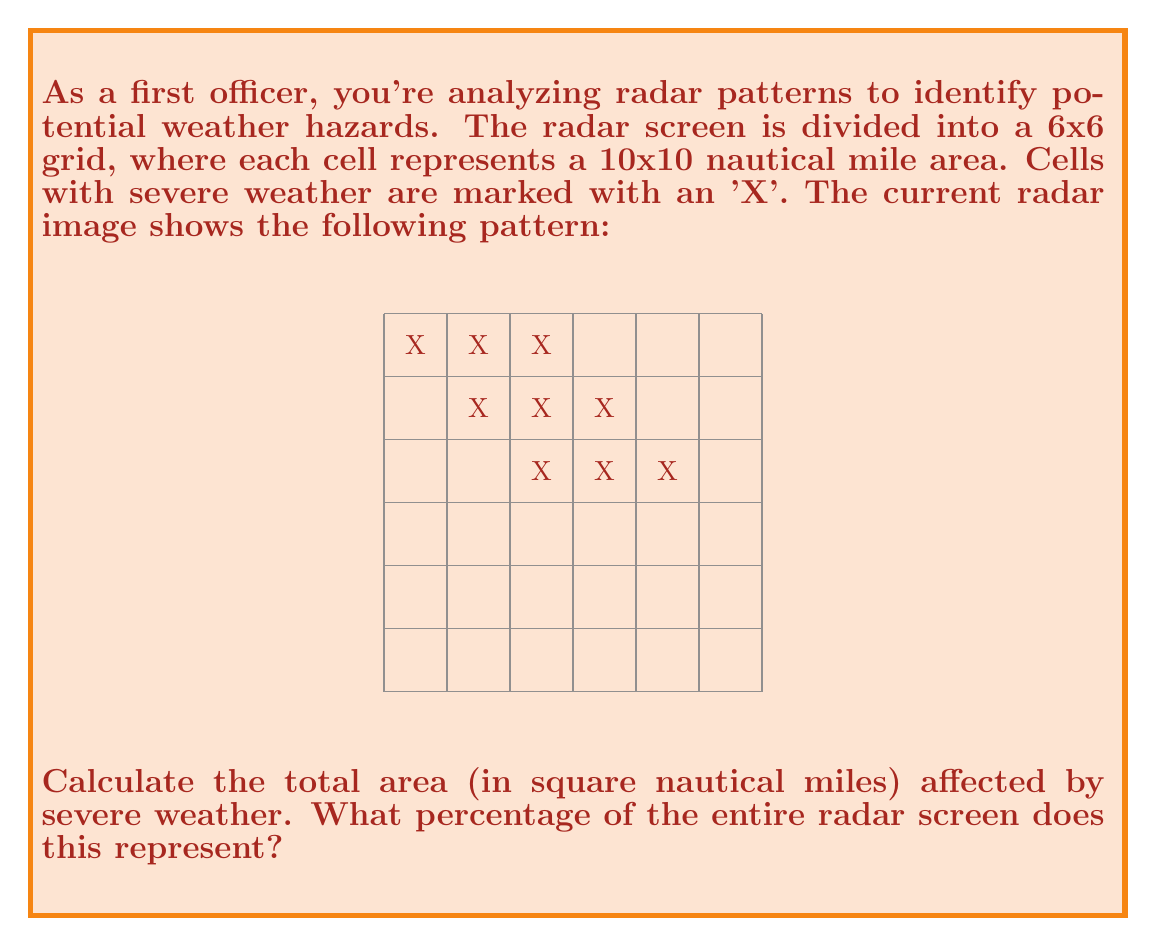Can you solve this math problem? Let's approach this step-by-step:

1. Count the number of cells marked with 'X':
   There are 9 cells marked with 'X'.

2. Calculate the area of each cell:
   Each cell represents a 10x10 nautical mile area.
   Area per cell = $10 \times 10 = 100$ square nautical miles

3. Calculate the total area affected by severe weather:
   Total affected area = Number of marked cells × Area per cell
   $$ \text{Total affected area} = 9 \times 100 = 900 \text{ square nautical miles} $$

4. Calculate the total area of the radar screen:
   The screen is a 6x6 grid, so it's 60x60 nautical miles.
   $$ \text{Total screen area} = 60 \times 60 = 3600 \text{ square nautical miles} $$

5. Calculate the percentage of the screen affected:
   $$ \text{Percentage} = \frac{\text{Affected area}}{\text{Total area}} \times 100\% $$
   $$ = \frac{900}{3600} \times 100\% = 0.25 \times 100\% = 25\% $$

Therefore, 900 square nautical miles are affected by severe weather, which represents 25% of the entire radar screen.
Answer: 900 sq nm, 25% 